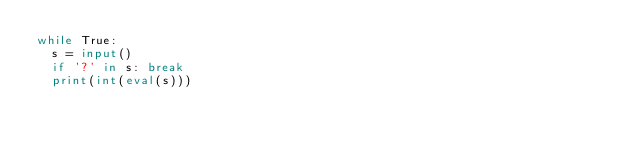<code> <loc_0><loc_0><loc_500><loc_500><_Python_>while True:
  s = input()
  if '?' in s: break
  print(int(eval(s)))
</code> 